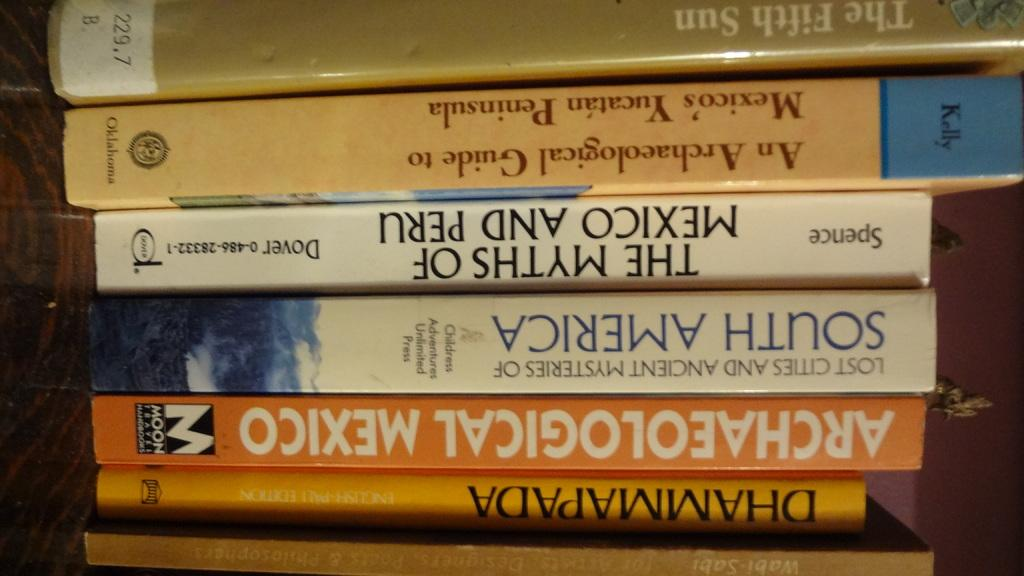Provide a one-sentence caption for the provided image. a book that reads The Myths of Mexico and Peru. 